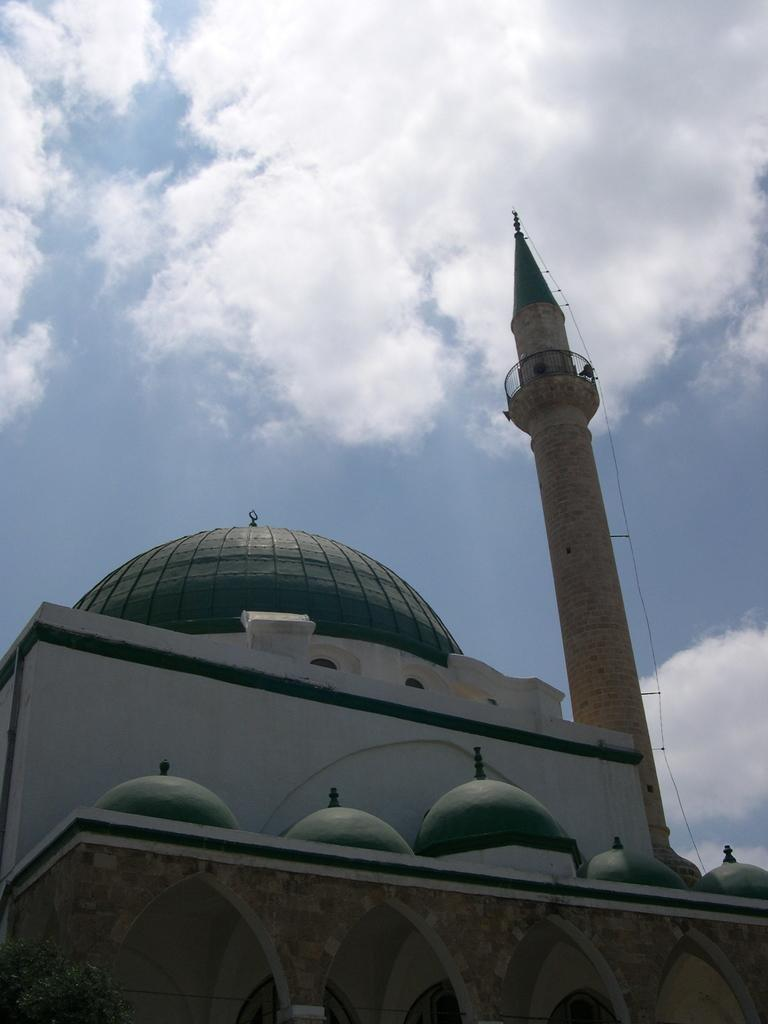What type of structure is present in the image? There is a building and a tower in the image. Can you describe the background of the image? The sky is visible in the background of the image. What can be seen in the sky? There are clouds in the sky. How many cows are grazing in the field near the building in the image? There are no cows or fields present in the image; it features a building and a tower with a sky background. What type of attraction is located near the building in the image? There is no specific attraction mentioned or visible in the image; it only shows a building and a tower with a sky background. 